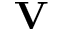<formula> <loc_0><loc_0><loc_500><loc_500>V</formula> 